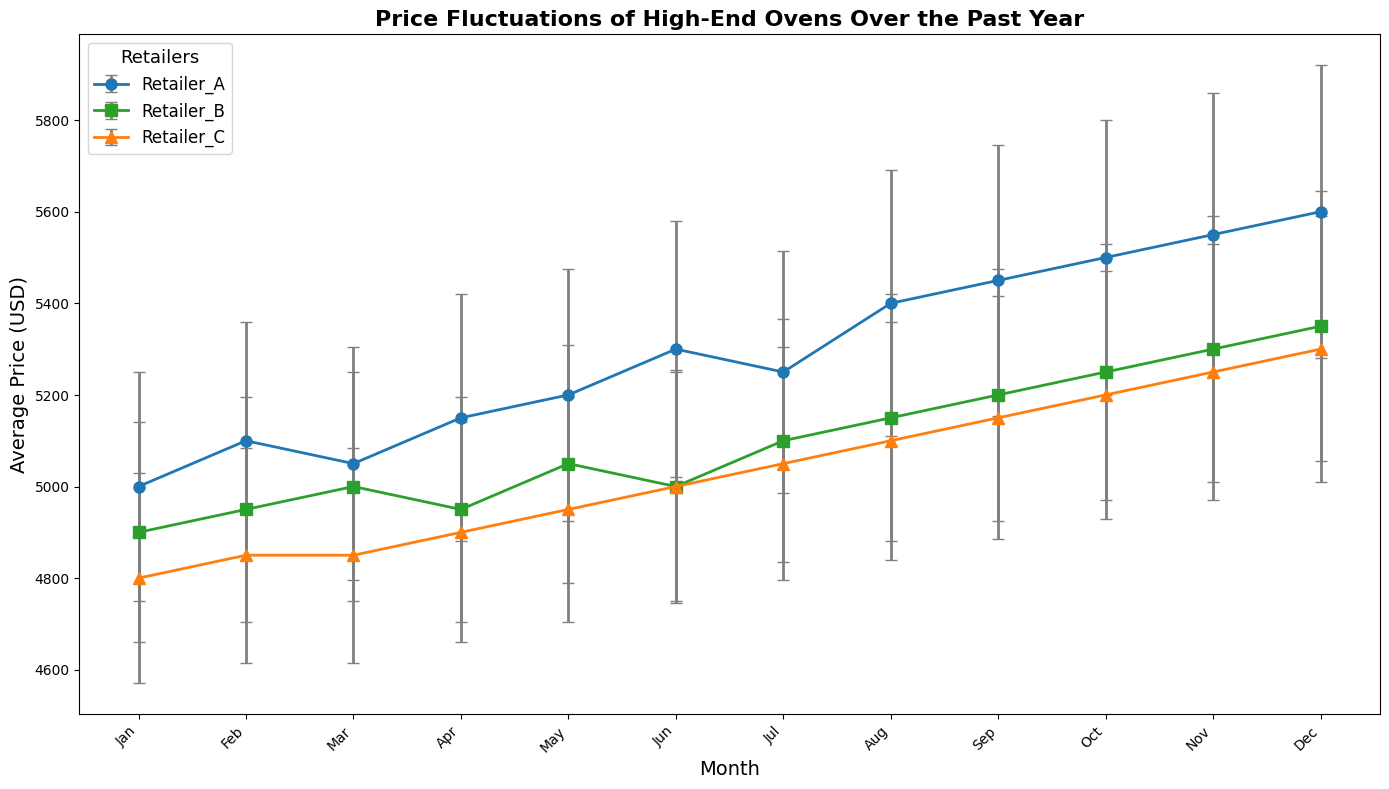How does the average price of high-end ovens from Retailer A in December compare to that of Retailer C in December? To compare the prices, look at December data points for both Retailers A and C. Retailer A's average price in December is 5600 USD, and Retailer C's average price is 5300 USD.
Answer: Retailer A is 300 USD higher Which retailer has the highest average price fluctuation throughout the year based on error bars? To determine this, examine the lengths of error bars for each retailer across all months. Retailer A has consistently larger error bars, indicating higher standard deviations (fluctuations) compared to Retailers B and C.
Answer: Retailer A Among Retailers A, B, and C, which one has the lowest average price for high-end ovens in March? To answer, check the average prices in March for each retailer. Retailer A is 5050 USD, Retailer B is 5000 USD, and Retailer C is 4850 USD.
Answer: Retailer C In which month is the difference in the average price of high-end ovens between Retailer A and Retailer B the smallest? Review the differences between the prices for A and B for each month. The smallest difference is in March (5050 USD for A vs 5000 USD for B) after computing the month-to-month differences.
Answer: March What are the highest and lowest average prices recorded by any retailer in any month for high-end ovens? Identify the maximum and minimum average prices across all months and retailers. The highest average price is 5600 USD (Retailer A in December), and the lowest is 4800 USD (Retailer C in January).
Answer: Highest: 5600 USD, Lowest: 4800 USD Which retailer shows a generally increasing trend in the average price of ovens over the year? To find this, review the overall trend in the plotted lines. Retailer A and Retailer C exhibit a generally increasing trend, but particularly Retailer A shows the strongest increasing trend.
Answer: Retailer A Does any retailer have an average price for high-end ovens that remains constant for two consecutive months? Check for any flat segments in the plotted lines. Retailer C shows an average price of 4850 USD for both February and March.
Answer: Retailer C What is the total cumulative increase in the average price of high-end ovens for Retailer B from January to December? Calculate the increase month-by-month and sum them: (4950-4900) + (5000-4950) + (4950-5000) + (5050-4950) + (5000-5050) + (5100-5000) + (5150-5100) + (5200-5150) + (5250-5200) + (5300-5250) + (5350-5300) = 450 USD.
Answer: 450 USD Among the retailers, which has the smallest standard deviation in average prices in December? Compare the standard deviation in December for all retailers. Retailer A's standard deviation is 320, Retailer B's is 295, and Retailer C's is 290.
Answer: Retailer C 